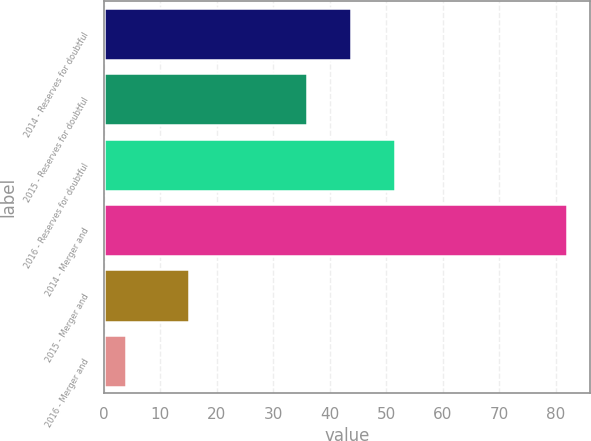<chart> <loc_0><loc_0><loc_500><loc_500><bar_chart><fcel>2014 - Reserves for doubtful<fcel>2015 - Reserves for doubtful<fcel>2016 - Reserves for doubtful<fcel>2014 - Merger and<fcel>2015 - Merger and<fcel>2016 - Merger and<nl><fcel>43.8<fcel>36<fcel>51.6<fcel>82<fcel>15<fcel>4<nl></chart> 